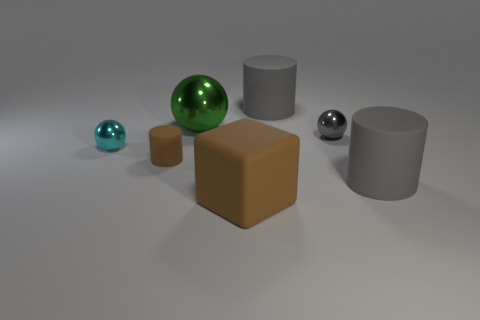Is there a specific lighting direction in this scene and how does it affect the objects? The lighting in the scene seems to come from above, slightly to the right, as indicated by the shadows directed toward the lower left. It highlights the textures and reflective qualities of the objects, providing depth and enhancing their three-dimensionality. 